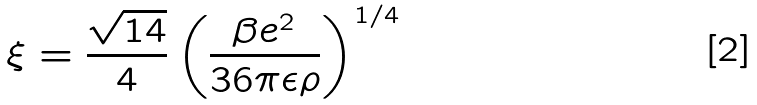Convert formula to latex. <formula><loc_0><loc_0><loc_500><loc_500>\xi = \frac { \sqrt { 1 4 } } { 4 } \left ( \frac { \beta e ^ { 2 } } { 3 6 \pi \epsilon \rho } \right ) ^ { 1 / 4 }</formula> 